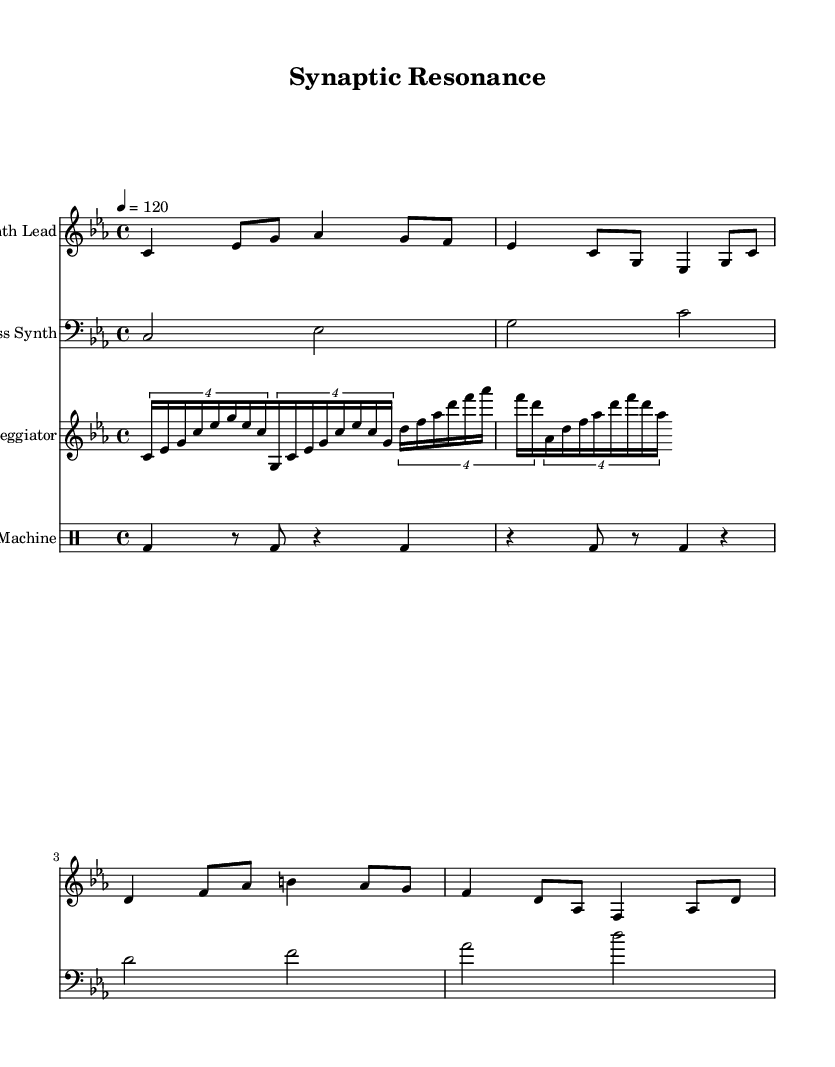What is the key signature of this music? The music is in C minor, which is indicated by the presence of three flats in the key signature. The flats correlate with the notes B, E, and A.
Answer: C minor What is the time signature of this piece? The time signature is displayed at the beginning of the score as 4/4, which means there are four beats in each measure and the quarter note gets one beat.
Answer: 4/4 What is the tempo marking for the piece? The tempo marking is indicated in the score as "4 = 120", which means there are 120 beats per minute. This is typically considered a moderate tempo for electronic music.
Answer: 120 How many instruments are used in this piece? The score presents four distinct staves, indicating four separate instruments: Synth Lead, Bass Synth, Arpeggiator, and Drum Machine.
Answer: Four Which section of the score features the fastest notes? The Arpeggiator section includes the fastest note values, as it uses sixteenth notes in tuplets, creating a quick rhythmic pattern as it transitions through multiple pitches.
Answer: Arpeggiator What note does the synth lead start on? The Synth Lead begins on a C note (the first note in the staff), which establishes the tonality of the piece and begins the melodic sequence.
Answer: C What type of drum pattern is featured in this music? The drum pattern is characterized by a four-on-the-floor kick drum, indicated by the bass drum (bd) in the drum machine section, which is typical in electronic music genres.
Answer: Four-on-the-floor 